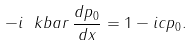Convert formula to latex. <formula><loc_0><loc_0><loc_500><loc_500>- i \ k b a r \, \frac { d p _ { 0 } } { d x } = 1 - i c p _ { 0 } .</formula> 